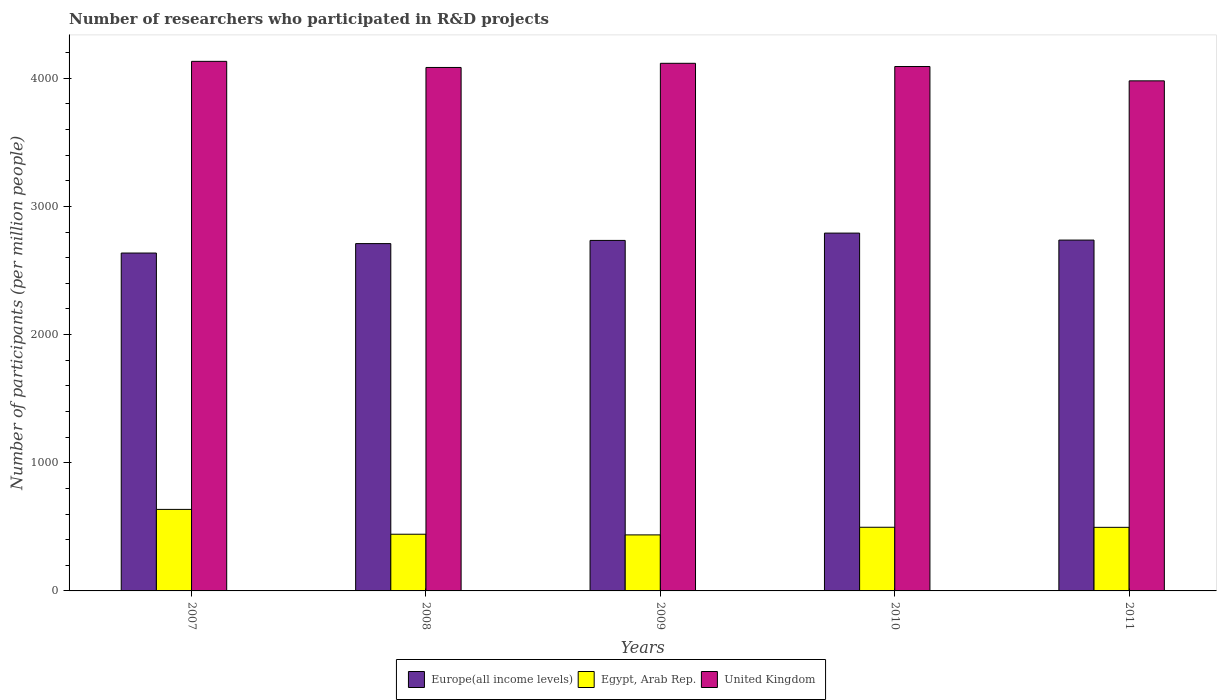Are the number of bars per tick equal to the number of legend labels?
Make the answer very short. Yes. Are the number of bars on each tick of the X-axis equal?
Your answer should be very brief. Yes. How many bars are there on the 3rd tick from the right?
Your answer should be very brief. 3. What is the number of researchers who participated in R&D projects in United Kingdom in 2009?
Offer a terse response. 4116.35. Across all years, what is the maximum number of researchers who participated in R&D projects in Egypt, Arab Rep.?
Provide a succinct answer. 636.08. Across all years, what is the minimum number of researchers who participated in R&D projects in Europe(all income levels)?
Your answer should be compact. 2636.01. In which year was the number of researchers who participated in R&D projects in Europe(all income levels) maximum?
Your answer should be compact. 2010. What is the total number of researchers who participated in R&D projects in United Kingdom in the graph?
Your answer should be very brief. 2.04e+04. What is the difference between the number of researchers who participated in R&D projects in Egypt, Arab Rep. in 2008 and that in 2010?
Ensure brevity in your answer.  -54.46. What is the difference between the number of researchers who participated in R&D projects in Europe(all income levels) in 2011 and the number of researchers who participated in R&D projects in United Kingdom in 2009?
Offer a very short reply. -1379.21. What is the average number of researchers who participated in R&D projects in United Kingdom per year?
Your response must be concise. 4080.46. In the year 2009, what is the difference between the number of researchers who participated in R&D projects in Europe(all income levels) and number of researchers who participated in R&D projects in United Kingdom?
Your answer should be compact. -1381.78. In how many years, is the number of researchers who participated in R&D projects in Egypt, Arab Rep. greater than 600?
Your answer should be compact. 1. What is the ratio of the number of researchers who participated in R&D projects in Europe(all income levels) in 2009 to that in 2010?
Give a very brief answer. 0.98. What is the difference between the highest and the second highest number of researchers who participated in R&D projects in United Kingdom?
Make the answer very short. 15.18. What is the difference between the highest and the lowest number of researchers who participated in R&D projects in United Kingdom?
Provide a short and direct response. 152.15. In how many years, is the number of researchers who participated in R&D projects in Europe(all income levels) greater than the average number of researchers who participated in R&D projects in Europe(all income levels) taken over all years?
Your answer should be compact. 3. What does the 3rd bar from the left in 2007 represents?
Provide a short and direct response. United Kingdom. What does the 3rd bar from the right in 2010 represents?
Your response must be concise. Europe(all income levels). Is it the case that in every year, the sum of the number of researchers who participated in R&D projects in United Kingdom and number of researchers who participated in R&D projects in Egypt, Arab Rep. is greater than the number of researchers who participated in R&D projects in Europe(all income levels)?
Provide a short and direct response. Yes. How many years are there in the graph?
Provide a succinct answer. 5. What is the difference between two consecutive major ticks on the Y-axis?
Offer a terse response. 1000. Where does the legend appear in the graph?
Provide a succinct answer. Bottom center. What is the title of the graph?
Your answer should be very brief. Number of researchers who participated in R&D projects. What is the label or title of the Y-axis?
Your answer should be very brief. Number of participants (per million people). What is the Number of participants (per million people) of Europe(all income levels) in 2007?
Your answer should be very brief. 2636.01. What is the Number of participants (per million people) of Egypt, Arab Rep. in 2007?
Offer a terse response. 636.08. What is the Number of participants (per million people) in United Kingdom in 2007?
Offer a very short reply. 4131.53. What is the Number of participants (per million people) in Europe(all income levels) in 2008?
Offer a very short reply. 2709.66. What is the Number of participants (per million people) in Egypt, Arab Rep. in 2008?
Offer a terse response. 442.27. What is the Number of participants (per million people) of United Kingdom in 2008?
Ensure brevity in your answer.  4083.86. What is the Number of participants (per million people) in Europe(all income levels) in 2009?
Ensure brevity in your answer.  2734.57. What is the Number of participants (per million people) in Egypt, Arab Rep. in 2009?
Ensure brevity in your answer.  437.06. What is the Number of participants (per million people) in United Kingdom in 2009?
Give a very brief answer. 4116.35. What is the Number of participants (per million people) of Europe(all income levels) in 2010?
Provide a short and direct response. 2791.64. What is the Number of participants (per million people) in Egypt, Arab Rep. in 2010?
Offer a very short reply. 496.73. What is the Number of participants (per million people) of United Kingdom in 2010?
Your answer should be very brief. 4091.18. What is the Number of participants (per million people) of Europe(all income levels) in 2011?
Your response must be concise. 2737.14. What is the Number of participants (per million people) in Egypt, Arab Rep. in 2011?
Provide a succinct answer. 496.12. What is the Number of participants (per million people) of United Kingdom in 2011?
Give a very brief answer. 3979.38. Across all years, what is the maximum Number of participants (per million people) in Europe(all income levels)?
Ensure brevity in your answer.  2791.64. Across all years, what is the maximum Number of participants (per million people) of Egypt, Arab Rep.?
Your answer should be very brief. 636.08. Across all years, what is the maximum Number of participants (per million people) of United Kingdom?
Your response must be concise. 4131.53. Across all years, what is the minimum Number of participants (per million people) of Europe(all income levels)?
Your answer should be compact. 2636.01. Across all years, what is the minimum Number of participants (per million people) in Egypt, Arab Rep.?
Offer a terse response. 437.06. Across all years, what is the minimum Number of participants (per million people) in United Kingdom?
Offer a very short reply. 3979.38. What is the total Number of participants (per million people) of Europe(all income levels) in the graph?
Make the answer very short. 1.36e+04. What is the total Number of participants (per million people) of Egypt, Arab Rep. in the graph?
Keep it short and to the point. 2508.25. What is the total Number of participants (per million people) of United Kingdom in the graph?
Give a very brief answer. 2.04e+04. What is the difference between the Number of participants (per million people) in Europe(all income levels) in 2007 and that in 2008?
Your answer should be compact. -73.65. What is the difference between the Number of participants (per million people) of Egypt, Arab Rep. in 2007 and that in 2008?
Make the answer very short. 193.81. What is the difference between the Number of participants (per million people) of United Kingdom in 2007 and that in 2008?
Your answer should be compact. 47.67. What is the difference between the Number of participants (per million people) of Europe(all income levels) in 2007 and that in 2009?
Provide a short and direct response. -98.56. What is the difference between the Number of participants (per million people) in Egypt, Arab Rep. in 2007 and that in 2009?
Give a very brief answer. 199.02. What is the difference between the Number of participants (per million people) of United Kingdom in 2007 and that in 2009?
Your response must be concise. 15.18. What is the difference between the Number of participants (per million people) in Europe(all income levels) in 2007 and that in 2010?
Make the answer very short. -155.63. What is the difference between the Number of participants (per million people) of Egypt, Arab Rep. in 2007 and that in 2010?
Your response must be concise. 139.35. What is the difference between the Number of participants (per million people) in United Kingdom in 2007 and that in 2010?
Give a very brief answer. 40.36. What is the difference between the Number of participants (per million people) of Europe(all income levels) in 2007 and that in 2011?
Keep it short and to the point. -101.12. What is the difference between the Number of participants (per million people) of Egypt, Arab Rep. in 2007 and that in 2011?
Offer a terse response. 139.96. What is the difference between the Number of participants (per million people) in United Kingdom in 2007 and that in 2011?
Ensure brevity in your answer.  152.15. What is the difference between the Number of participants (per million people) of Europe(all income levels) in 2008 and that in 2009?
Ensure brevity in your answer.  -24.91. What is the difference between the Number of participants (per million people) of Egypt, Arab Rep. in 2008 and that in 2009?
Offer a very short reply. 5.21. What is the difference between the Number of participants (per million people) of United Kingdom in 2008 and that in 2009?
Ensure brevity in your answer.  -32.49. What is the difference between the Number of participants (per million people) of Europe(all income levels) in 2008 and that in 2010?
Offer a very short reply. -81.98. What is the difference between the Number of participants (per million people) of Egypt, Arab Rep. in 2008 and that in 2010?
Your answer should be very brief. -54.46. What is the difference between the Number of participants (per million people) of United Kingdom in 2008 and that in 2010?
Make the answer very short. -7.32. What is the difference between the Number of participants (per million people) in Europe(all income levels) in 2008 and that in 2011?
Provide a short and direct response. -27.48. What is the difference between the Number of participants (per million people) of Egypt, Arab Rep. in 2008 and that in 2011?
Offer a terse response. -53.85. What is the difference between the Number of participants (per million people) in United Kingdom in 2008 and that in 2011?
Your answer should be compact. 104.48. What is the difference between the Number of participants (per million people) of Europe(all income levels) in 2009 and that in 2010?
Keep it short and to the point. -57.07. What is the difference between the Number of participants (per million people) in Egypt, Arab Rep. in 2009 and that in 2010?
Offer a very short reply. -59.67. What is the difference between the Number of participants (per million people) of United Kingdom in 2009 and that in 2010?
Your answer should be very brief. 25.17. What is the difference between the Number of participants (per million people) in Europe(all income levels) in 2009 and that in 2011?
Offer a very short reply. -2.56. What is the difference between the Number of participants (per million people) of Egypt, Arab Rep. in 2009 and that in 2011?
Provide a short and direct response. -59.06. What is the difference between the Number of participants (per million people) in United Kingdom in 2009 and that in 2011?
Offer a terse response. 136.97. What is the difference between the Number of participants (per million people) of Europe(all income levels) in 2010 and that in 2011?
Your answer should be compact. 54.5. What is the difference between the Number of participants (per million people) in Egypt, Arab Rep. in 2010 and that in 2011?
Offer a very short reply. 0.61. What is the difference between the Number of participants (per million people) in United Kingdom in 2010 and that in 2011?
Ensure brevity in your answer.  111.79. What is the difference between the Number of participants (per million people) of Europe(all income levels) in 2007 and the Number of participants (per million people) of Egypt, Arab Rep. in 2008?
Provide a succinct answer. 2193.74. What is the difference between the Number of participants (per million people) of Europe(all income levels) in 2007 and the Number of participants (per million people) of United Kingdom in 2008?
Your response must be concise. -1447.85. What is the difference between the Number of participants (per million people) of Egypt, Arab Rep. in 2007 and the Number of participants (per million people) of United Kingdom in 2008?
Your response must be concise. -3447.78. What is the difference between the Number of participants (per million people) in Europe(all income levels) in 2007 and the Number of participants (per million people) in Egypt, Arab Rep. in 2009?
Provide a short and direct response. 2198.95. What is the difference between the Number of participants (per million people) of Europe(all income levels) in 2007 and the Number of participants (per million people) of United Kingdom in 2009?
Provide a short and direct response. -1480.34. What is the difference between the Number of participants (per million people) in Egypt, Arab Rep. in 2007 and the Number of participants (per million people) in United Kingdom in 2009?
Provide a succinct answer. -3480.27. What is the difference between the Number of participants (per million people) of Europe(all income levels) in 2007 and the Number of participants (per million people) of Egypt, Arab Rep. in 2010?
Provide a succinct answer. 2139.28. What is the difference between the Number of participants (per million people) of Europe(all income levels) in 2007 and the Number of participants (per million people) of United Kingdom in 2010?
Offer a terse response. -1455.16. What is the difference between the Number of participants (per million people) in Egypt, Arab Rep. in 2007 and the Number of participants (per million people) in United Kingdom in 2010?
Offer a terse response. -3455.1. What is the difference between the Number of participants (per million people) of Europe(all income levels) in 2007 and the Number of participants (per million people) of Egypt, Arab Rep. in 2011?
Keep it short and to the point. 2139.9. What is the difference between the Number of participants (per million people) of Europe(all income levels) in 2007 and the Number of participants (per million people) of United Kingdom in 2011?
Offer a terse response. -1343.37. What is the difference between the Number of participants (per million people) in Egypt, Arab Rep. in 2007 and the Number of participants (per million people) in United Kingdom in 2011?
Your answer should be compact. -3343.31. What is the difference between the Number of participants (per million people) of Europe(all income levels) in 2008 and the Number of participants (per million people) of Egypt, Arab Rep. in 2009?
Provide a short and direct response. 2272.6. What is the difference between the Number of participants (per million people) of Europe(all income levels) in 2008 and the Number of participants (per million people) of United Kingdom in 2009?
Make the answer very short. -1406.69. What is the difference between the Number of participants (per million people) of Egypt, Arab Rep. in 2008 and the Number of participants (per million people) of United Kingdom in 2009?
Make the answer very short. -3674.08. What is the difference between the Number of participants (per million people) in Europe(all income levels) in 2008 and the Number of participants (per million people) in Egypt, Arab Rep. in 2010?
Provide a succinct answer. 2212.93. What is the difference between the Number of participants (per million people) of Europe(all income levels) in 2008 and the Number of participants (per million people) of United Kingdom in 2010?
Provide a short and direct response. -1381.52. What is the difference between the Number of participants (per million people) in Egypt, Arab Rep. in 2008 and the Number of participants (per million people) in United Kingdom in 2010?
Provide a succinct answer. -3648.91. What is the difference between the Number of participants (per million people) in Europe(all income levels) in 2008 and the Number of participants (per million people) in Egypt, Arab Rep. in 2011?
Make the answer very short. 2213.54. What is the difference between the Number of participants (per million people) of Europe(all income levels) in 2008 and the Number of participants (per million people) of United Kingdom in 2011?
Keep it short and to the point. -1269.72. What is the difference between the Number of participants (per million people) in Egypt, Arab Rep. in 2008 and the Number of participants (per million people) in United Kingdom in 2011?
Offer a terse response. -3537.11. What is the difference between the Number of participants (per million people) of Europe(all income levels) in 2009 and the Number of participants (per million people) of Egypt, Arab Rep. in 2010?
Offer a terse response. 2237.84. What is the difference between the Number of participants (per million people) in Europe(all income levels) in 2009 and the Number of participants (per million people) in United Kingdom in 2010?
Offer a terse response. -1356.6. What is the difference between the Number of participants (per million people) in Egypt, Arab Rep. in 2009 and the Number of participants (per million people) in United Kingdom in 2010?
Provide a succinct answer. -3654.12. What is the difference between the Number of participants (per million people) in Europe(all income levels) in 2009 and the Number of participants (per million people) in Egypt, Arab Rep. in 2011?
Give a very brief answer. 2238.46. What is the difference between the Number of participants (per million people) in Europe(all income levels) in 2009 and the Number of participants (per million people) in United Kingdom in 2011?
Give a very brief answer. -1244.81. What is the difference between the Number of participants (per million people) of Egypt, Arab Rep. in 2009 and the Number of participants (per million people) of United Kingdom in 2011?
Your answer should be compact. -3542.33. What is the difference between the Number of participants (per million people) of Europe(all income levels) in 2010 and the Number of participants (per million people) of Egypt, Arab Rep. in 2011?
Your answer should be very brief. 2295.52. What is the difference between the Number of participants (per million people) in Europe(all income levels) in 2010 and the Number of participants (per million people) in United Kingdom in 2011?
Your answer should be compact. -1187.75. What is the difference between the Number of participants (per million people) of Egypt, Arab Rep. in 2010 and the Number of participants (per million people) of United Kingdom in 2011?
Provide a short and direct response. -3482.66. What is the average Number of participants (per million people) in Europe(all income levels) per year?
Provide a succinct answer. 2721.8. What is the average Number of participants (per million people) in Egypt, Arab Rep. per year?
Give a very brief answer. 501.65. What is the average Number of participants (per million people) of United Kingdom per year?
Offer a very short reply. 4080.46. In the year 2007, what is the difference between the Number of participants (per million people) of Europe(all income levels) and Number of participants (per million people) of Egypt, Arab Rep.?
Provide a succinct answer. 1999.94. In the year 2007, what is the difference between the Number of participants (per million people) of Europe(all income levels) and Number of participants (per million people) of United Kingdom?
Offer a very short reply. -1495.52. In the year 2007, what is the difference between the Number of participants (per million people) of Egypt, Arab Rep. and Number of participants (per million people) of United Kingdom?
Provide a succinct answer. -3495.46. In the year 2008, what is the difference between the Number of participants (per million people) of Europe(all income levels) and Number of participants (per million people) of Egypt, Arab Rep.?
Provide a short and direct response. 2267.39. In the year 2008, what is the difference between the Number of participants (per million people) of Europe(all income levels) and Number of participants (per million people) of United Kingdom?
Give a very brief answer. -1374.2. In the year 2008, what is the difference between the Number of participants (per million people) in Egypt, Arab Rep. and Number of participants (per million people) in United Kingdom?
Your answer should be compact. -3641.59. In the year 2009, what is the difference between the Number of participants (per million people) of Europe(all income levels) and Number of participants (per million people) of Egypt, Arab Rep.?
Your answer should be compact. 2297.51. In the year 2009, what is the difference between the Number of participants (per million people) in Europe(all income levels) and Number of participants (per million people) in United Kingdom?
Your answer should be compact. -1381.78. In the year 2009, what is the difference between the Number of participants (per million people) of Egypt, Arab Rep. and Number of participants (per million people) of United Kingdom?
Make the answer very short. -3679.29. In the year 2010, what is the difference between the Number of participants (per million people) of Europe(all income levels) and Number of participants (per million people) of Egypt, Arab Rep.?
Your response must be concise. 2294.91. In the year 2010, what is the difference between the Number of participants (per million people) of Europe(all income levels) and Number of participants (per million people) of United Kingdom?
Provide a succinct answer. -1299.54. In the year 2010, what is the difference between the Number of participants (per million people) of Egypt, Arab Rep. and Number of participants (per million people) of United Kingdom?
Make the answer very short. -3594.45. In the year 2011, what is the difference between the Number of participants (per million people) in Europe(all income levels) and Number of participants (per million people) in Egypt, Arab Rep.?
Offer a very short reply. 2241.02. In the year 2011, what is the difference between the Number of participants (per million people) in Europe(all income levels) and Number of participants (per million people) in United Kingdom?
Make the answer very short. -1242.25. In the year 2011, what is the difference between the Number of participants (per million people) of Egypt, Arab Rep. and Number of participants (per million people) of United Kingdom?
Offer a terse response. -3483.27. What is the ratio of the Number of participants (per million people) of Europe(all income levels) in 2007 to that in 2008?
Make the answer very short. 0.97. What is the ratio of the Number of participants (per million people) of Egypt, Arab Rep. in 2007 to that in 2008?
Provide a short and direct response. 1.44. What is the ratio of the Number of participants (per million people) in United Kingdom in 2007 to that in 2008?
Make the answer very short. 1.01. What is the ratio of the Number of participants (per million people) of Europe(all income levels) in 2007 to that in 2009?
Provide a short and direct response. 0.96. What is the ratio of the Number of participants (per million people) in Egypt, Arab Rep. in 2007 to that in 2009?
Provide a succinct answer. 1.46. What is the ratio of the Number of participants (per million people) in United Kingdom in 2007 to that in 2009?
Your answer should be compact. 1. What is the ratio of the Number of participants (per million people) in Europe(all income levels) in 2007 to that in 2010?
Your answer should be compact. 0.94. What is the ratio of the Number of participants (per million people) in Egypt, Arab Rep. in 2007 to that in 2010?
Ensure brevity in your answer.  1.28. What is the ratio of the Number of participants (per million people) of United Kingdom in 2007 to that in 2010?
Offer a very short reply. 1.01. What is the ratio of the Number of participants (per million people) in Europe(all income levels) in 2007 to that in 2011?
Keep it short and to the point. 0.96. What is the ratio of the Number of participants (per million people) of Egypt, Arab Rep. in 2007 to that in 2011?
Keep it short and to the point. 1.28. What is the ratio of the Number of participants (per million people) in United Kingdom in 2007 to that in 2011?
Make the answer very short. 1.04. What is the ratio of the Number of participants (per million people) of Europe(all income levels) in 2008 to that in 2009?
Your answer should be compact. 0.99. What is the ratio of the Number of participants (per million people) in Egypt, Arab Rep. in 2008 to that in 2009?
Your answer should be very brief. 1.01. What is the ratio of the Number of participants (per million people) in Europe(all income levels) in 2008 to that in 2010?
Provide a short and direct response. 0.97. What is the ratio of the Number of participants (per million people) of Egypt, Arab Rep. in 2008 to that in 2010?
Make the answer very short. 0.89. What is the ratio of the Number of participants (per million people) of Egypt, Arab Rep. in 2008 to that in 2011?
Provide a short and direct response. 0.89. What is the ratio of the Number of participants (per million people) of United Kingdom in 2008 to that in 2011?
Ensure brevity in your answer.  1.03. What is the ratio of the Number of participants (per million people) of Europe(all income levels) in 2009 to that in 2010?
Offer a very short reply. 0.98. What is the ratio of the Number of participants (per million people) of Egypt, Arab Rep. in 2009 to that in 2010?
Keep it short and to the point. 0.88. What is the ratio of the Number of participants (per million people) of Europe(all income levels) in 2009 to that in 2011?
Make the answer very short. 1. What is the ratio of the Number of participants (per million people) in Egypt, Arab Rep. in 2009 to that in 2011?
Your answer should be very brief. 0.88. What is the ratio of the Number of participants (per million people) in United Kingdom in 2009 to that in 2011?
Your answer should be compact. 1.03. What is the ratio of the Number of participants (per million people) of Europe(all income levels) in 2010 to that in 2011?
Keep it short and to the point. 1.02. What is the ratio of the Number of participants (per million people) in Egypt, Arab Rep. in 2010 to that in 2011?
Give a very brief answer. 1. What is the ratio of the Number of participants (per million people) in United Kingdom in 2010 to that in 2011?
Give a very brief answer. 1.03. What is the difference between the highest and the second highest Number of participants (per million people) in Europe(all income levels)?
Your answer should be compact. 54.5. What is the difference between the highest and the second highest Number of participants (per million people) in Egypt, Arab Rep.?
Ensure brevity in your answer.  139.35. What is the difference between the highest and the second highest Number of participants (per million people) in United Kingdom?
Provide a succinct answer. 15.18. What is the difference between the highest and the lowest Number of participants (per million people) of Europe(all income levels)?
Your answer should be very brief. 155.63. What is the difference between the highest and the lowest Number of participants (per million people) in Egypt, Arab Rep.?
Make the answer very short. 199.02. What is the difference between the highest and the lowest Number of participants (per million people) of United Kingdom?
Your response must be concise. 152.15. 